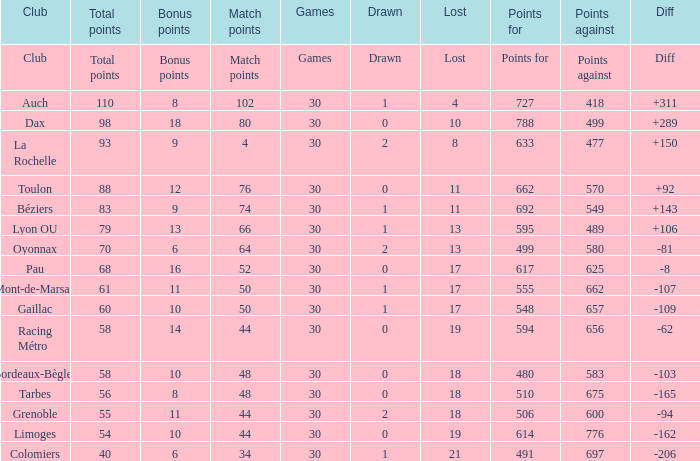How many bonus points did the Colomiers earn? 6.0. 